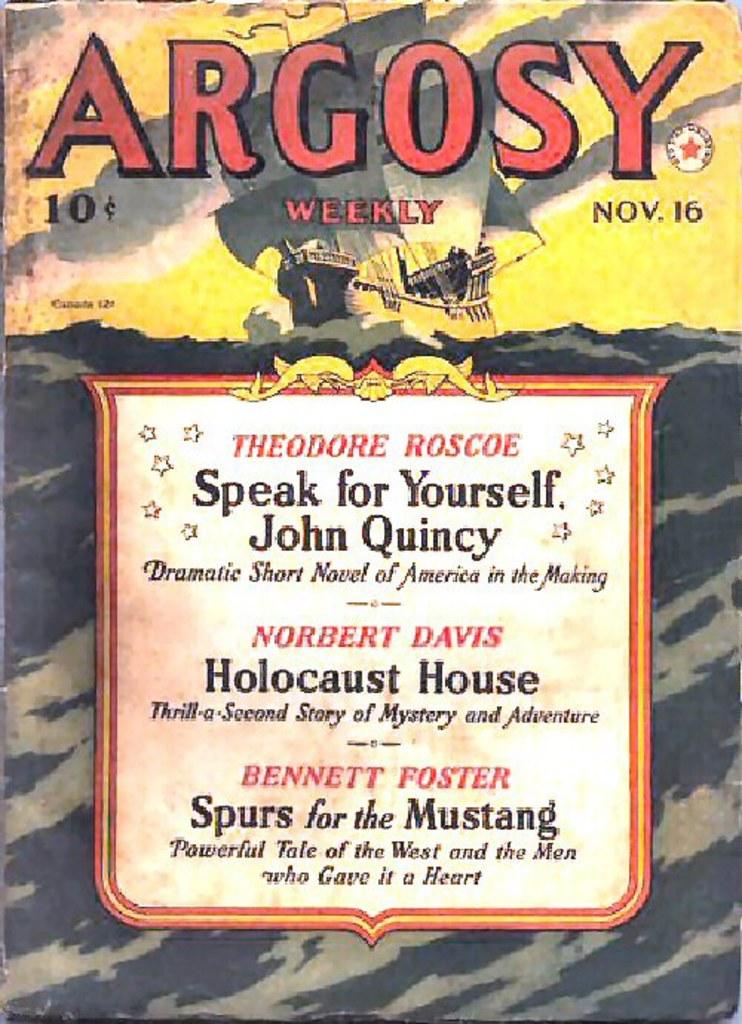What month was this published in?
Offer a terse response. November. What is the price listed on the top left?
Provide a short and direct response. 10 cents. 